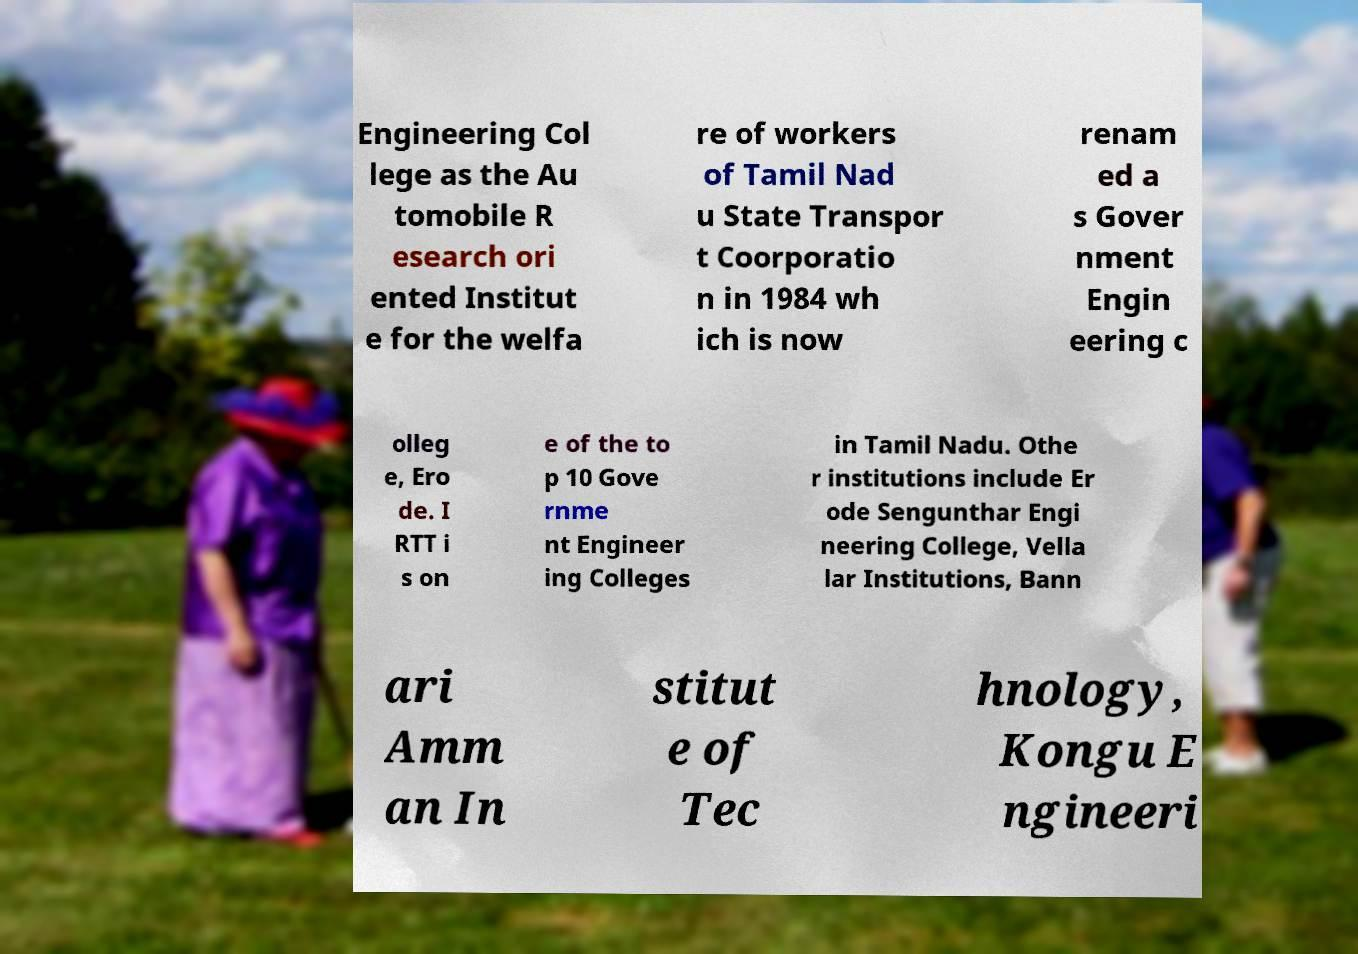Please identify and transcribe the text found in this image. Engineering Col lege as the Au tomobile R esearch ori ented Institut e for the welfa re of workers of Tamil Nad u State Transpor t Coorporatio n in 1984 wh ich is now renam ed a s Gover nment Engin eering c olleg e, Ero de. I RTT i s on e of the to p 10 Gove rnme nt Engineer ing Colleges in Tamil Nadu. Othe r institutions include Er ode Sengunthar Engi neering College, Vella lar Institutions, Bann ari Amm an In stitut e of Tec hnology, Kongu E ngineeri 